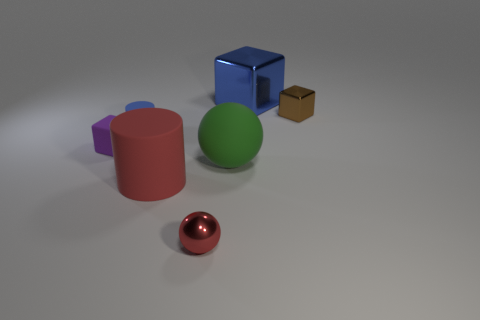The thing that is the same color as the big block is what size?
Your answer should be very brief. Small. There is a metal ball; is its color the same as the rubber object that is in front of the big green matte ball?
Give a very brief answer. Yes. Are there the same number of rubber cylinders in front of the tiny ball and blue things in front of the big red matte cylinder?
Give a very brief answer. Yes. There is a large matte thing on the left side of the small sphere; is it the same shape as the small blue rubber thing?
Give a very brief answer. Yes. What is the shape of the small red thing in front of the blue object behind the small matte thing that is behind the matte cube?
Your answer should be very brief. Sphere. There is a matte object that is the same color as the large metallic object; what shape is it?
Make the answer very short. Cylinder. What is the tiny object that is both to the left of the small brown cube and behind the matte block made of?
Ensure brevity in your answer.  Rubber. Is the number of purple rubber cubes less than the number of tiny green balls?
Give a very brief answer. No. Does the large blue object have the same shape as the blue object that is left of the big sphere?
Ensure brevity in your answer.  No. Is the size of the block that is to the left of the red metal ball the same as the tiny blue thing?
Provide a short and direct response. Yes. 